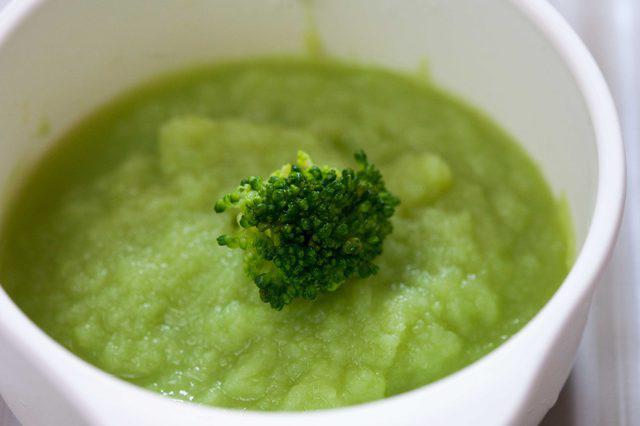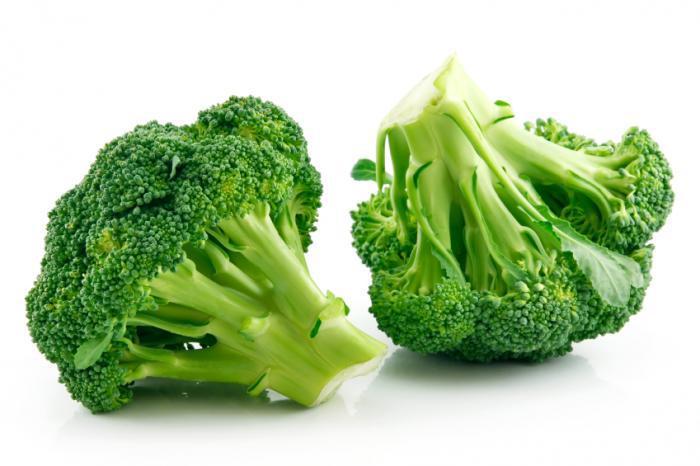The first image is the image on the left, the second image is the image on the right. For the images displayed, is the sentence "An image shows a white bowl that contains some broccoli stalks." factually correct? Answer yes or no. No. The first image is the image on the left, the second image is the image on the right. Assess this claim about the two images: "The broccoli in the image on the right is in a white bowl.". Correct or not? Answer yes or no. No. 